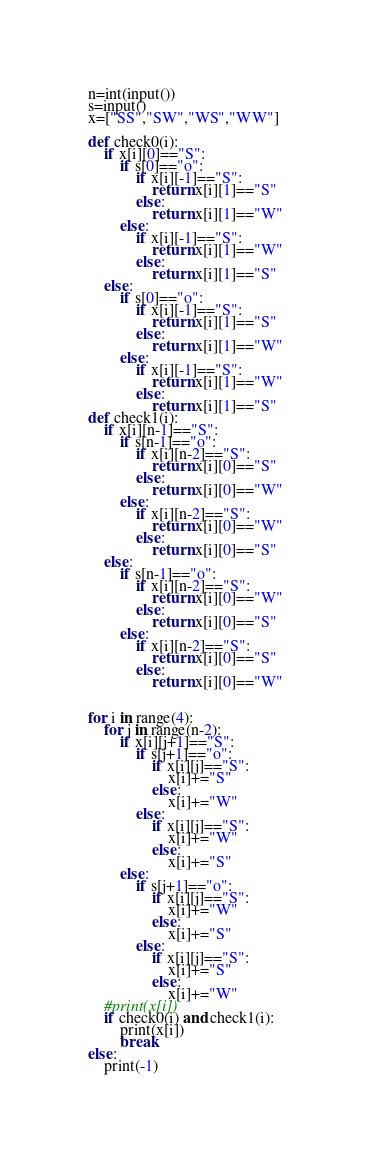<code> <loc_0><loc_0><loc_500><loc_500><_Python_>n=int(input())
s=input()
x=["SS","SW","WS","WW"]

def check0(i):
    if x[i][0]=="S":
        if s[0]=="o":
            if x[i][-1]=="S":
                return x[i][1]=="S"
            else:
                return x[i][1]=="W"
        else:
            if x[i][-1]=="S":
                return x[i][1]=="W"
            else:
                return x[i][1]=="S"
    else:
        if s[0]=="o":
            if x[i][-1]=="S":
                return x[i][1]=="S"
            else:
                return x[i][1]=="W"
        else:
            if x[i][-1]=="S":
                return x[i][1]=="W"
            else:
                return x[i][1]=="S"
def check1(i):
    if x[i][n-1]=="S":
        if s[n-1]=="o":
            if x[i][n-2]=="S":
                return x[i][0]=="S"
            else:
                return x[i][0]=="W"
        else:
            if x[i][n-2]=="S":
                return x[i][0]=="W"
            else:
                return x[i][0]=="S"
    else:
        if s[n-1]=="o":
            if x[i][n-2]=="S":
                return x[i][0]=="W"
            else:
                return x[i][0]=="S"
        else:
            if x[i][n-2]=="S":
                return x[i][0]=="S"
            else:
                return x[i][0]=="W"


for i in range(4):
    for j in range(n-2):
        if x[i][j+1]=="S":
            if s[j+1]=="o":
                if x[i][j]=="S":
                    x[i]+="S"
                else:
                    x[i]+="W"
            else:
                if x[i][j]=="S":
                    x[i]+="W"
                else:
                    x[i]+="S"
        else:
            if s[j+1]=="o":
                if x[i][j]=="S":
                    x[i]+="W"
                else:
                    x[i]+="S"
            else:
                if x[i][j]=="S":
                    x[i]+="S"
                else:
                    x[i]+="W"
    #print(x[i])
    if check0(i) and check1(i):
        print(x[i])
        break
else:
    print(-1)
</code> 